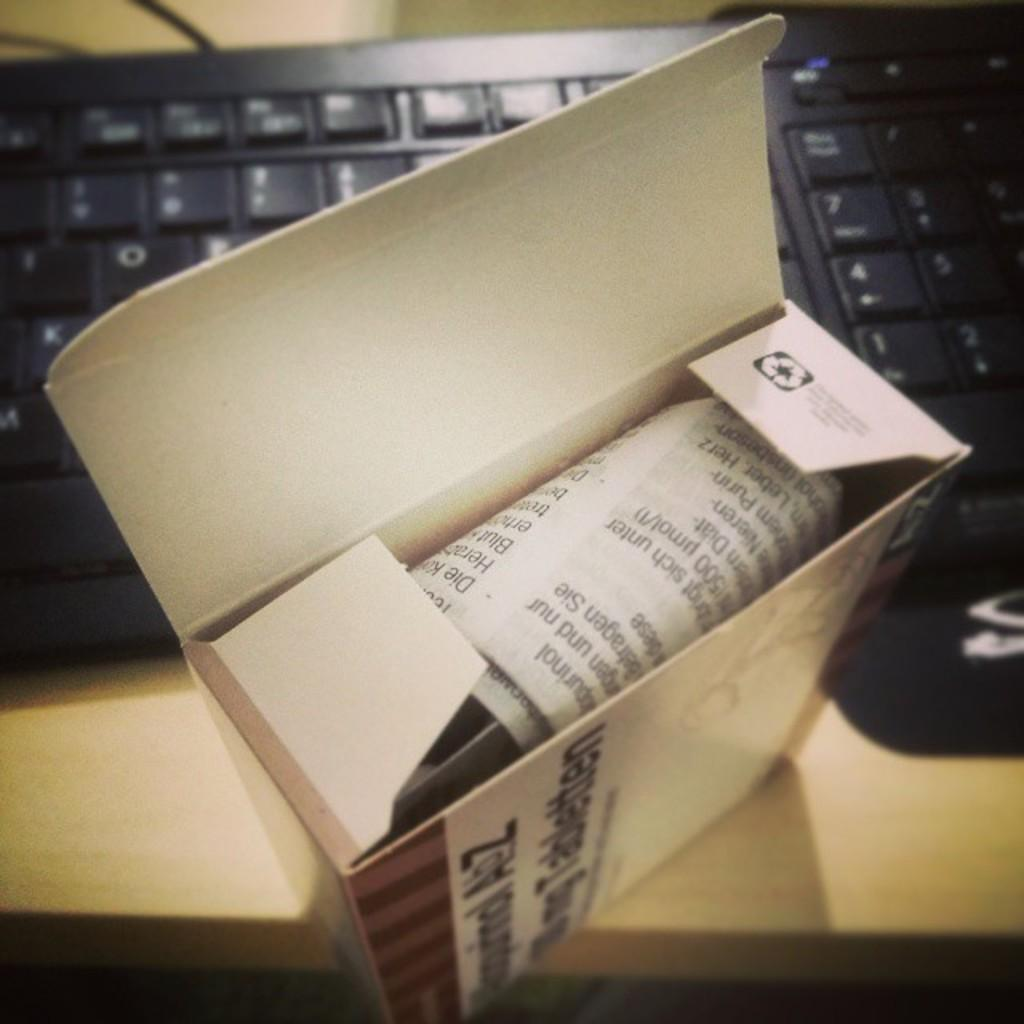<image>
Present a compact description of the photo's key features. Box sitting in front of a keyboard that has instructions inside with the letters Die on it. 